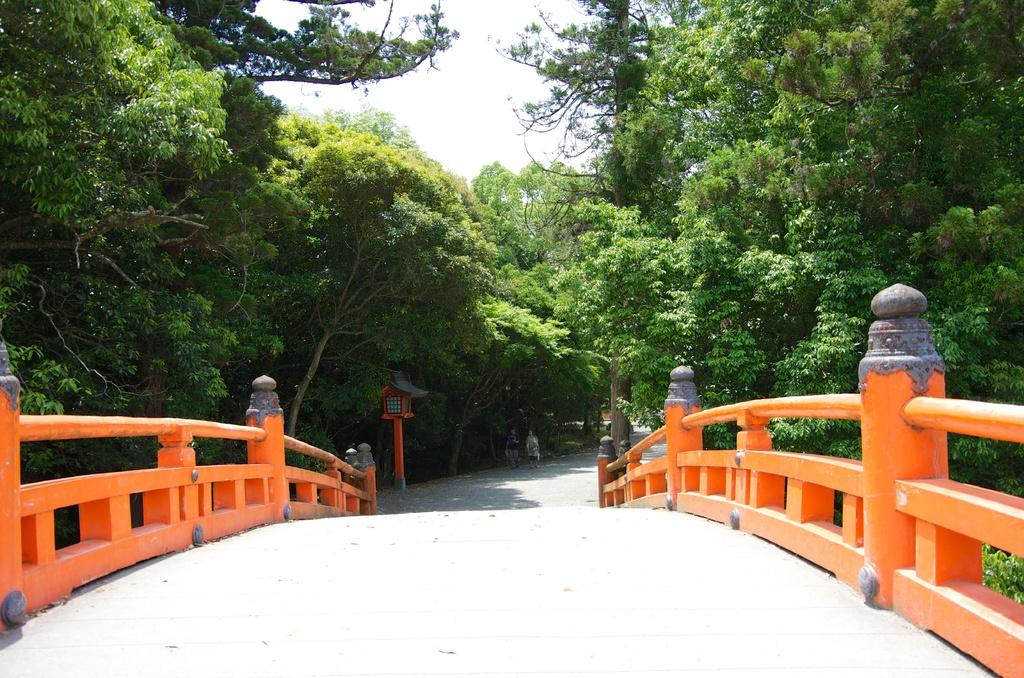What is located in the center of the image? There is a walkway in the center of the image. What can be seen in the background of the image? There are trees, persons, and a pole in the background of the image. What is the color of the pole in the image? The pole is red in color. What type of metal is the playground made of in the image? There is no playground present in the image, so it is not possible to determine what type of metal it might be made of. 